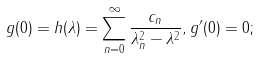Convert formula to latex. <formula><loc_0><loc_0><loc_500><loc_500>g ( 0 ) = h ( \lambda ) = \sum _ { n = 0 } ^ { \infty } { \frac { c _ { n } } { { \lambda _ { n } ^ { 2 } - { \lambda ^ { 2 } } } } } , g ^ { \prime } ( 0 ) = 0 ;</formula> 